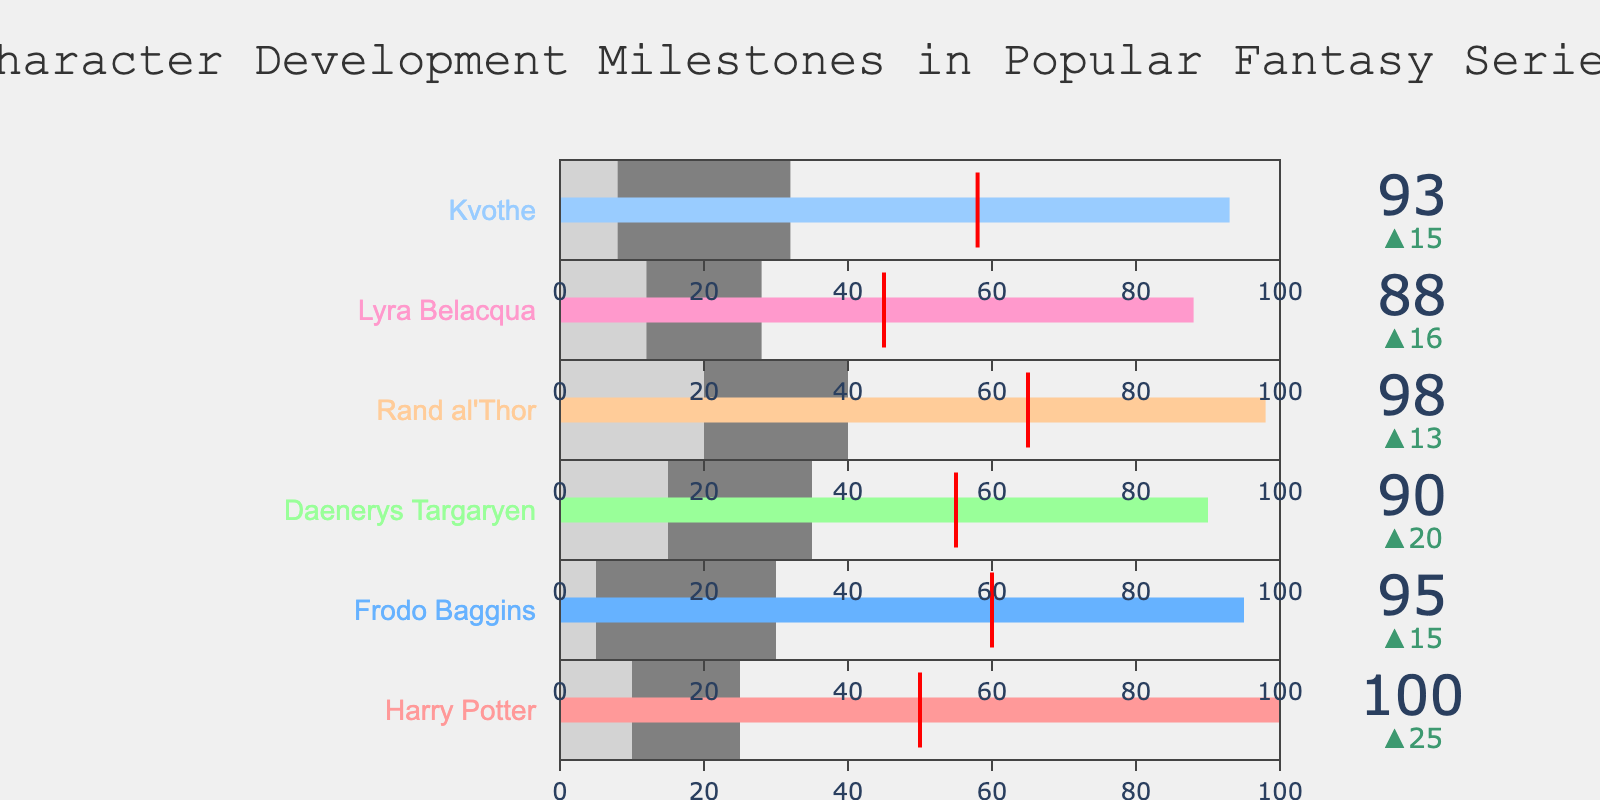What's the title of the figure? The title is located at the top of the figure and is typically larger and more prominent than other text elements.
Answer: Character Development Milestones in Popular Fantasy Series How many characters are represented in the figure? By counting the number of bullet charts, each corresponding to a unique character name, we determine the number of characters.
Answer: 6 Which character reaches the Final Battle milestone last? The Final Battle value indicates when each character reaches this milestone. Comparing the Final Battle values, Rand al'Thor reaches it at 98, which is the highest.
Answer: Rand al'Thor What value marks the beginning of Harry Potter's First Challenge? To the right of the Introduction milestone, the next significant value represents the First Challenge. According to the data, this happens at 25 for Harry Potter.
Answer: 25 Who has the smallest range between Introduction and Final Battle milestones? Calculate the difference between Final Battle and Introduction values for each character. The smallest difference indicates the answer. Lyra Belacqua has a range of 88 - 12 = 76.
Answer: Lyra Belacqua Which character faces their Major Conflict at the lowest value? Check the threshold value for each character's Major Conflict. Frodo Baggins faces his Major Conflict at the value of 60, which is the lowest among all characters.
Answer: Frodo Baggins How does Harry Potter's character growth compare to Frodo Baggins? Compare the Character Growth values: Harry Potter's is 75, and Frodo Baggins's is 80. Frodo Baggins's Character Growth is higher.
Answer: Frodo Baggins's character growth is higher What is unique about Lyra Belacqua's bullet chart compared to Kvothe's? Compare their bullet charts, focusing on the key milestones. Lyra reaches Major Conflict at 45, while Kvothe's Major Conflict is at 58. Also, Lyra's Final Battle is 88 and Kvothe's is 93.
Answer: Lyra faces Major Conflict earlier and has a lower Final Battle value 